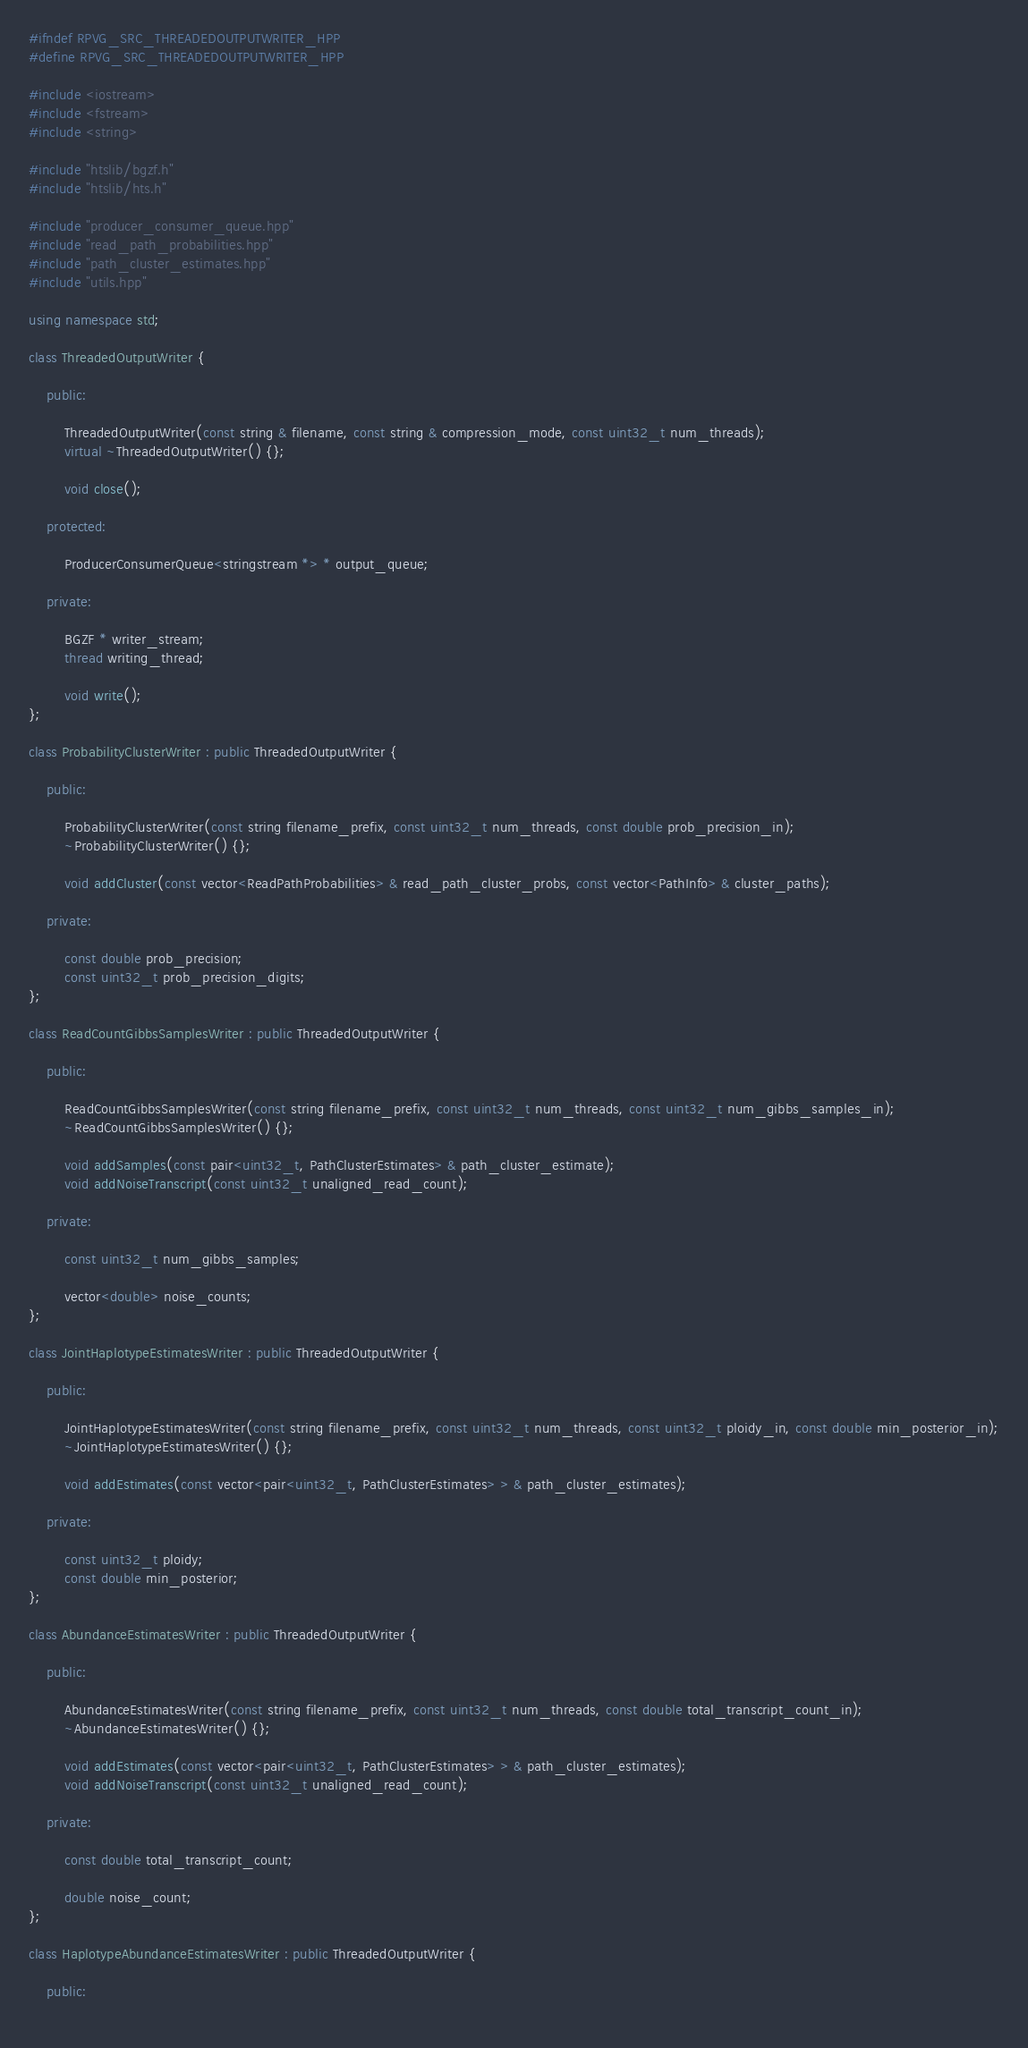Convert code to text. <code><loc_0><loc_0><loc_500><loc_500><_C++_>
#ifndef RPVG_SRC_THREADEDOUTPUTWRITER_HPP
#define RPVG_SRC_THREADEDOUTPUTWRITER_HPP

#include <iostream>
#include <fstream>
#include <string>

#include "htslib/bgzf.h"
#include "htslib/hts.h"

#include "producer_consumer_queue.hpp"
#include "read_path_probabilities.hpp"
#include "path_cluster_estimates.hpp"
#include "utils.hpp"

using namespace std;

class ThreadedOutputWriter {

    public: 

        ThreadedOutputWriter(const string & filename, const string & compression_mode, const uint32_t num_threads);
        virtual ~ThreadedOutputWriter() {};

        void close();

    protected:

        ProducerConsumerQueue<stringstream *> * output_queue;

    private:

        BGZF * writer_stream;
        thread writing_thread; 

        void write();
};

class ProbabilityClusterWriter : public ThreadedOutputWriter {

    public: 
        
        ProbabilityClusterWriter(const string filename_prefix, const uint32_t num_threads, const double prob_precision_in);
        ~ProbabilityClusterWriter() {};

        void addCluster(const vector<ReadPathProbabilities> & read_path_cluster_probs, const vector<PathInfo> & cluster_paths);

    private:

        const double prob_precision;
        const uint32_t prob_precision_digits;
};

class ReadCountGibbsSamplesWriter : public ThreadedOutputWriter {

    public: 
        
        ReadCountGibbsSamplesWriter(const string filename_prefix, const uint32_t num_threads, const uint32_t num_gibbs_samples_in);
        ~ReadCountGibbsSamplesWriter() {};

        void addSamples(const pair<uint32_t, PathClusterEstimates> & path_cluster_estimate);
        void addNoiseTranscript(const uint32_t unaligned_read_count);

    private:

        const uint32_t num_gibbs_samples;

        vector<double> noise_counts;
};

class JointHaplotypeEstimatesWriter : public ThreadedOutputWriter {

    public: 
        
        JointHaplotypeEstimatesWriter(const string filename_prefix, const uint32_t num_threads, const uint32_t ploidy_in, const double min_posterior_in);
        ~JointHaplotypeEstimatesWriter() {};

        void addEstimates(const vector<pair<uint32_t, PathClusterEstimates> > & path_cluster_estimates);

    private:

        const uint32_t ploidy;
        const double min_posterior;
};

class AbundanceEstimatesWriter : public ThreadedOutputWriter {

    public: 
        
        AbundanceEstimatesWriter(const string filename_prefix, const uint32_t num_threads, const double total_transcript_count_in);
        ~AbundanceEstimatesWriter() {};

        void addEstimates(const vector<pair<uint32_t, PathClusterEstimates> > & path_cluster_estimates);
        void addNoiseTranscript(const uint32_t unaligned_read_count);

    private:

        const double total_transcript_count;

        double noise_count;
};

class HaplotypeAbundanceEstimatesWriter : public ThreadedOutputWriter {

    public: 
    	</code> 